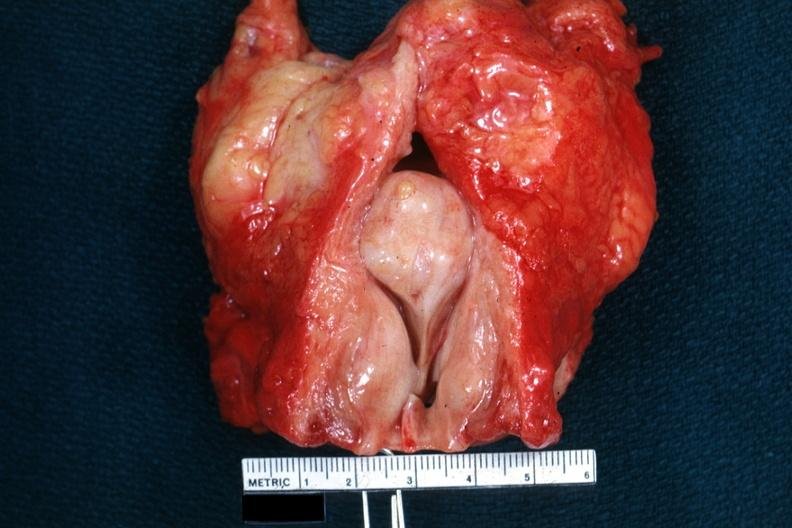does this image show large medial lobar so-called median bar does not show bladder well?
Answer the question using a single word or phrase. Yes 